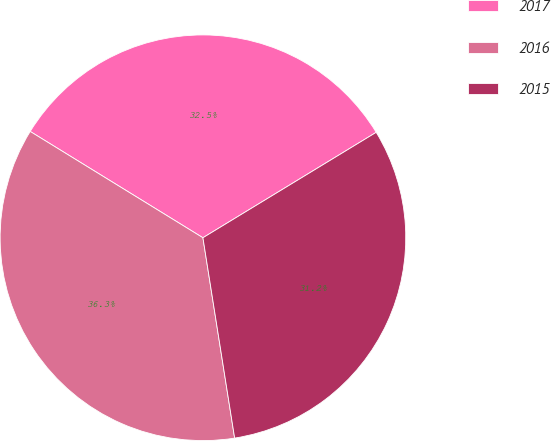Convert chart. <chart><loc_0><loc_0><loc_500><loc_500><pie_chart><fcel>2017<fcel>2016<fcel>2015<nl><fcel>32.52%<fcel>36.28%<fcel>31.2%<nl></chart> 